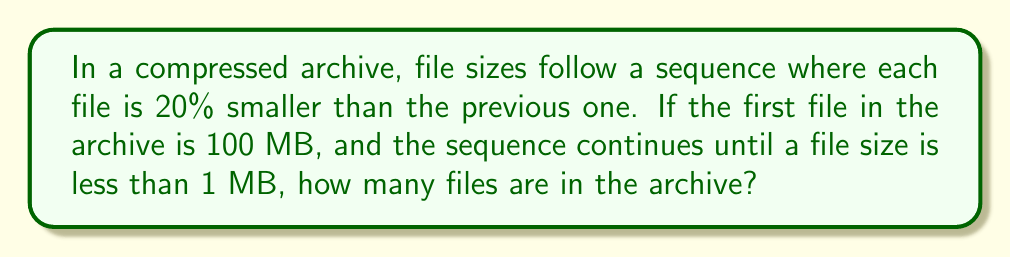Could you help me with this problem? Let's approach this step-by-step:

1) We start with 100 MB and each subsequent file is 80% of the previous (as it's 20% smaller).

2) Let's calculate the sequence:
   File 1: 100 MB
   File 2: $100 * 0.8 = 80$ MB
   File 3: $80 * 0.8 = 64$ MB
   File 4: $64 * 0.8 = 51.2$ MB
   File 5: $51.2 * 0.8 = 40.96$ MB
   File 6: $40.96 * 0.8 = 32.768$ MB
   File 7: $32.768 * 0.8 = 26.2144$ MB
   File 8: $26.2144 * 0.8 = 20.97152$ MB
   File 9: $20.97152 * 0.8 = 16.777216$ MB
   File 10: $16.777216 * 0.8 = 13.4217728$ MB
   File 11: $13.4217728 * 0.8 = 10.73741824$ MB
   File 12: $10.73741824 * 0.8 = 8.589934592$ MB
   File 13: $8.589934592 * 0.8 = 6.8719476736$ MB
   File 14: $6.8719476736 * 0.8 = 5.49755813888$ MB
   File 15: $5.49755813888 * 0.8 = 4.398046511104$ MB
   File 16: $4.398046511104 * 0.8 = 3.5184372088832$ MB
   File 17: $3.5184372088832 * 0.8 = 2.81474976710656$ MB
   File 18: $2.81474976710656 * 0.8 = 2.251799813685248$ MB
   File 19: $2.251799813685248 * 0.8 = 1.8014398509481984$ MB
   File 20: $1.8014398509481984 * 0.8 = 1.44115188075855872$ MB
   File 21: $1.44115188075855872 * 0.8 = 1.152921504606846976$ MB
   File 22: $1.152921504606846976 * 0.8 = 0.9223372036854775808$ MB

3) We stop at File 22 because File 23 would be less than 1 MB.

Therefore, there are 22 files in the archive.
Answer: 22 